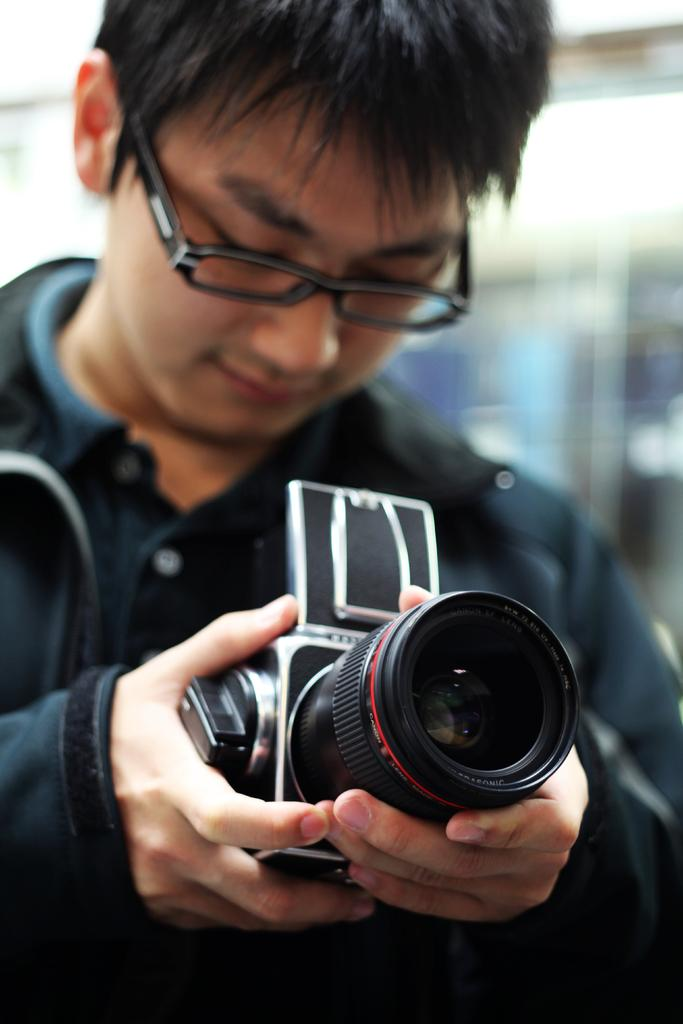What is present in the image? There is a man in the image. What is the man holding in his hand? The man is holding a camera in his hand. What type of cheese is the man using to take pictures in the image? There is no cheese present in the image, and the man is using a camera to take pictures. What type of bed is visible in the image? There is no bed present in the image. 